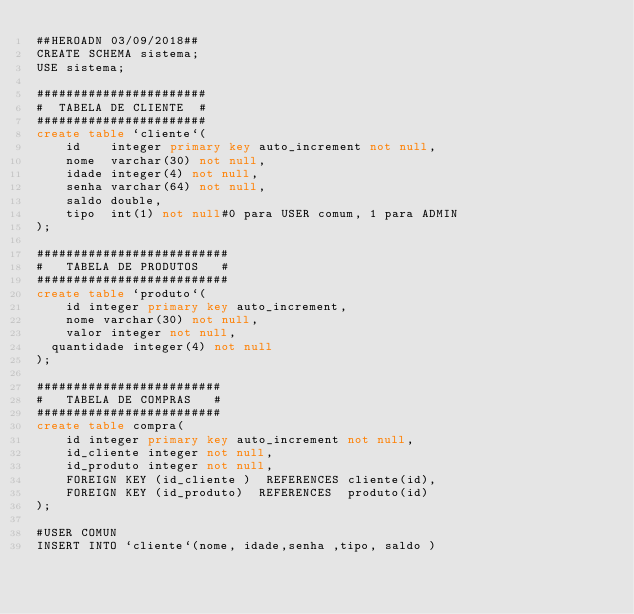<code> <loc_0><loc_0><loc_500><loc_500><_SQL_>##HEROADN 03/09/2018##
CREATE SCHEMA sistema;
USE sistema;

#######################
#  TABELA DE CLIENTE  #
#######################
create table `cliente`(
    id    integer primary key auto_increment not null,
    nome  varchar(30) not null,
    idade integer(4) not null,
    senha varchar(64) not null,
    saldo double,
    tipo  int(1) not null#0 para USER comum, 1 para ADMIN
);

##########################
#   TABELA DE PRODUTOS   #
##########################
create table `produto`(
    id integer primary key auto_increment,
    nome varchar(30) not null,
    valor integer not null,
	quantidade integer(4) not null
);

#########################
#   TABELA DE COMPRAS   #
#########################
create table compra(
    id integer primary key auto_increment not null,
    id_cliente integer not null,
    id_produto integer not null,
    FOREIGN KEY (id_cliente )  REFERENCES cliente(id),
    FOREIGN KEY (id_produto)  REFERENCES  produto(id)
);

#USER COMUN
INSERT INTO `cliente`(nome, idade,senha ,tipo, saldo ) </code> 